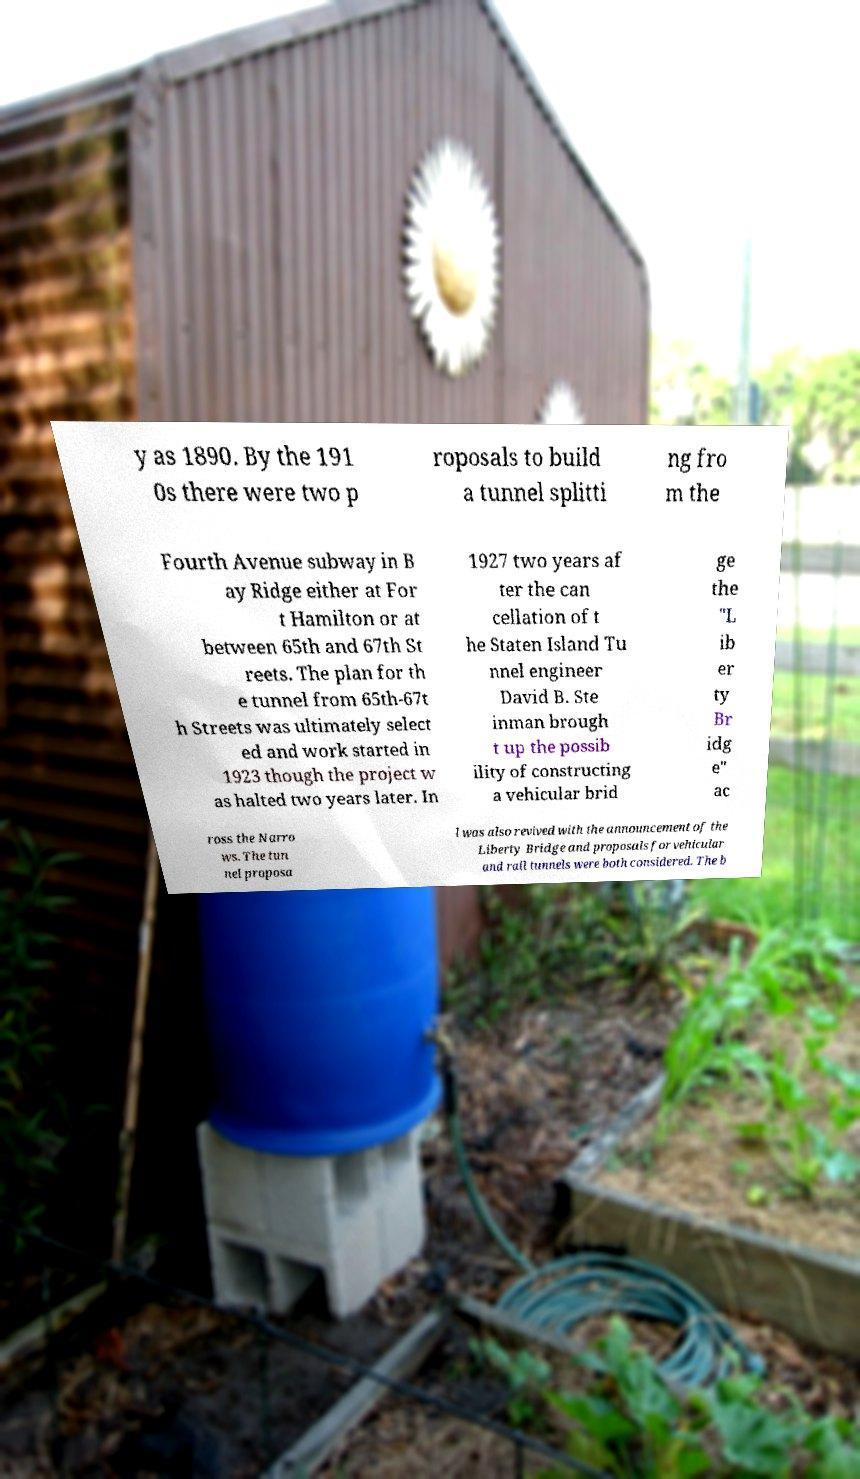For documentation purposes, I need the text within this image transcribed. Could you provide that? y as 1890. By the 191 0s there were two p roposals to build a tunnel splitti ng fro m the Fourth Avenue subway in B ay Ridge either at For t Hamilton or at between 65th and 67th St reets. The plan for th e tunnel from 65th-67t h Streets was ultimately select ed and work started in 1923 though the project w as halted two years later. In 1927 two years af ter the can cellation of t he Staten Island Tu nnel engineer David B. Ste inman brough t up the possib ility of constructing a vehicular brid ge the "L ib er ty Br idg e" ac ross the Narro ws. The tun nel proposa l was also revived with the announcement of the Liberty Bridge and proposals for vehicular and rail tunnels were both considered. The b 